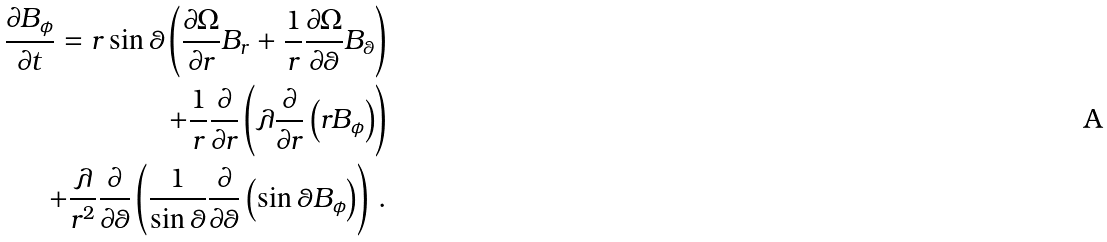<formula> <loc_0><loc_0><loc_500><loc_500>\frac { \partial B _ { \phi } } { \partial t } = r \sin \theta \left ( \frac { \partial \Omega } { \partial r } B _ { r } + \frac { 1 } { r } \frac { \partial \Omega } { \partial \theta } B _ { \theta } \right ) \\ + \frac { 1 } { r } \frac { \partial } { \partial r } \left ( \lambda \frac { \partial } { \partial r } \left ( r B _ { \phi } \right ) \right ) \\ + \frac { \lambda } { r ^ { 2 } } \frac { \partial } { \partial \theta } \left ( \frac { 1 } { \sin \theta } \frac { \partial } { \partial \theta } \left ( \sin \theta B _ { \phi } \right ) \right ) \, .</formula> 